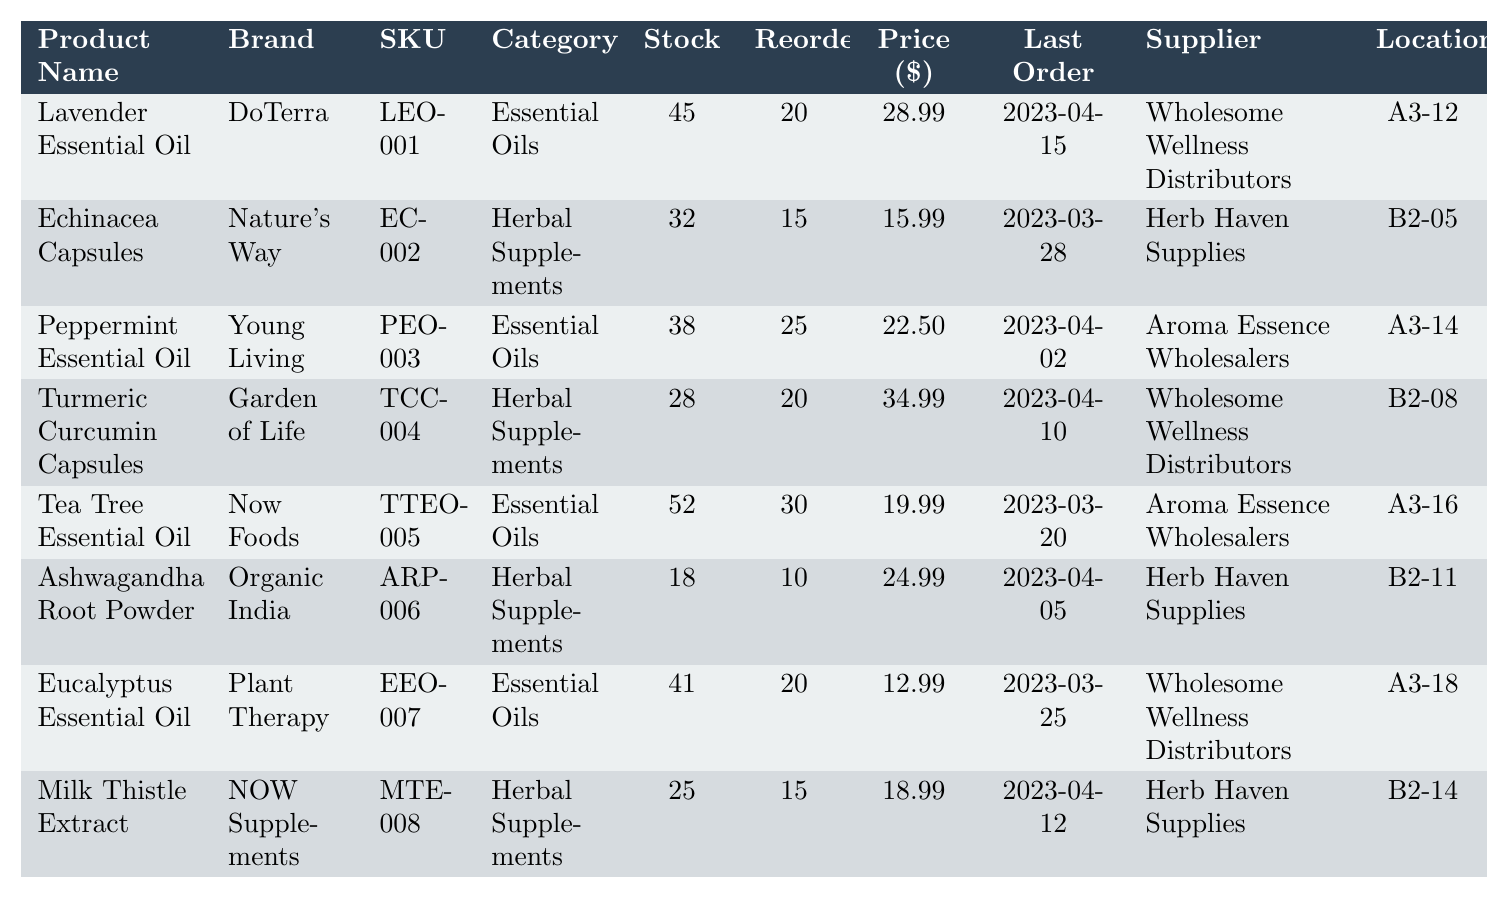What is the current stock of Echinacea Capsules? The table shows that the current stock for Echinacea Capsules is listed in the "Stock" column next to its name. It indicates a stock of 32.
Answer: 32 What is the unit price of Lavender Essential Oil? The unit price of Lavender Essential Oil can be found in the "Price ($)" column on the same row as the product name. It states that the unit price is $28.99.
Answer: 28.99 How many items have a reorder point of 20? To find this, you need to count the number of entries in the "Reorder" column that are equal to 20. The products with this value are Lavender Essential Oil, Eucalyptus Essential Oil, and Turmeric Curcumin Capsules, totaling 3 items.
Answer: 3 Is the last order date for Tea Tree Essential Oil more recent than that of Ashwagandha Root Powder? The last order date for Tea Tree Essential Oil is 2023-03-20 and for Ashwagandha Root Powder, it is 2023-04-05. Since 2023-03-20 is earlier than 2023-04-05, the statement is false.
Answer: No Which product has the highest unit price? To determine the highest unit price, compare all values in the "Price ($)" column. Turmeric Curcumin Capsules have the highest price at $34.99.
Answer: Turmeric Curcumin Capsules What is the total current stock of Essential Oils? Add the current stock numbers of all products in the "Essential Oils" category: Lavender Essential Oil (45), Peppermint Essential Oil (38), Tea Tree Essential Oil (52), and Eucalyptus Essential Oil (41). This totals 45 + 38 + 52 + 41 = 176.
Answer: 176 How many Herbal Supplements have a current stock below their reorder point? Review the current stock against the reorder points for Herbal Supplements. Ashwagandha Root Powder (18) and Turmeric Curcumin Capsules (28) have stock less than their reorder points of 10 and 20, respectively. Only Ashwagandha Root Powder qualifies, so the total is 1.
Answer: 1 What is the average unit price of products in the Herbal Supplements category? To find this average, sum the unit prices for all Herbal Supplements: Echinacea Capsules ($15.99), Turmeric Curcumin Capsules ($34.99), Ashwagandha Root Powder ($24.99), and Milk Thistle Extract ($18.99), which totals $15.99 + $34.99 + $24.99 + $18.99 = $94.96. Divide this by 4 (the number of products) gives an average of $94.96 / 4 = $23.74.
Answer: 23.74 Which supplier has provided the most products? Count the frequency of each supplier listed. Wholesome Wellness Distributors appears for Lavender Essential Oil, Turmeric Curcumin Capsules, and Eucalyptus Essential Oil (3 products), while Herb Haven Supplies appears for Echinacea Capsules and Milk Thistle Extract (2 products). Aroma Essence Wholesalers has 2 products as well. The highest is Wholesome Wellness Distributors with 3 products.
Answer: Wholesome Wellness Distributors Which product has the lowest current stock? Check the "Stock" column for the lowest value. It shows that Ashwagandha Root Powder has the lowest stock at 18.
Answer: Ashwagandha Root Powder 